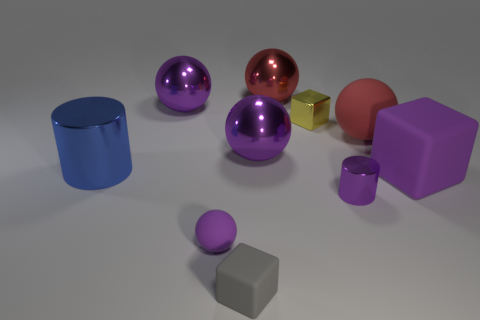Are there any objects that cast a shadow, and what does that indicate about the light source? In the image, each object casts a soft shadow, indicating that there is a diffuse light source above and to the right of the scene. The shadows are not very sharp, suggesting that the light source is not extremely close to the objects or that there is some ambient light softening the shadows. 